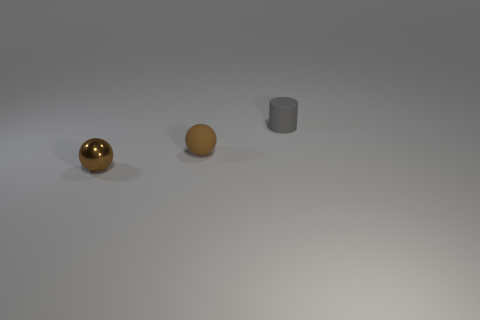Can you speculate on the sizes of the objects based on this perspective? Based on the perspective, the objects seem to vary in size. The golden sphere on the left may be approximately the size of a tennis ball, while the central sphere could be slightly larger, similar to a baseball. The gray object on the right, which could be a cylinder, might be akin to the size of a large cup or a small container. 